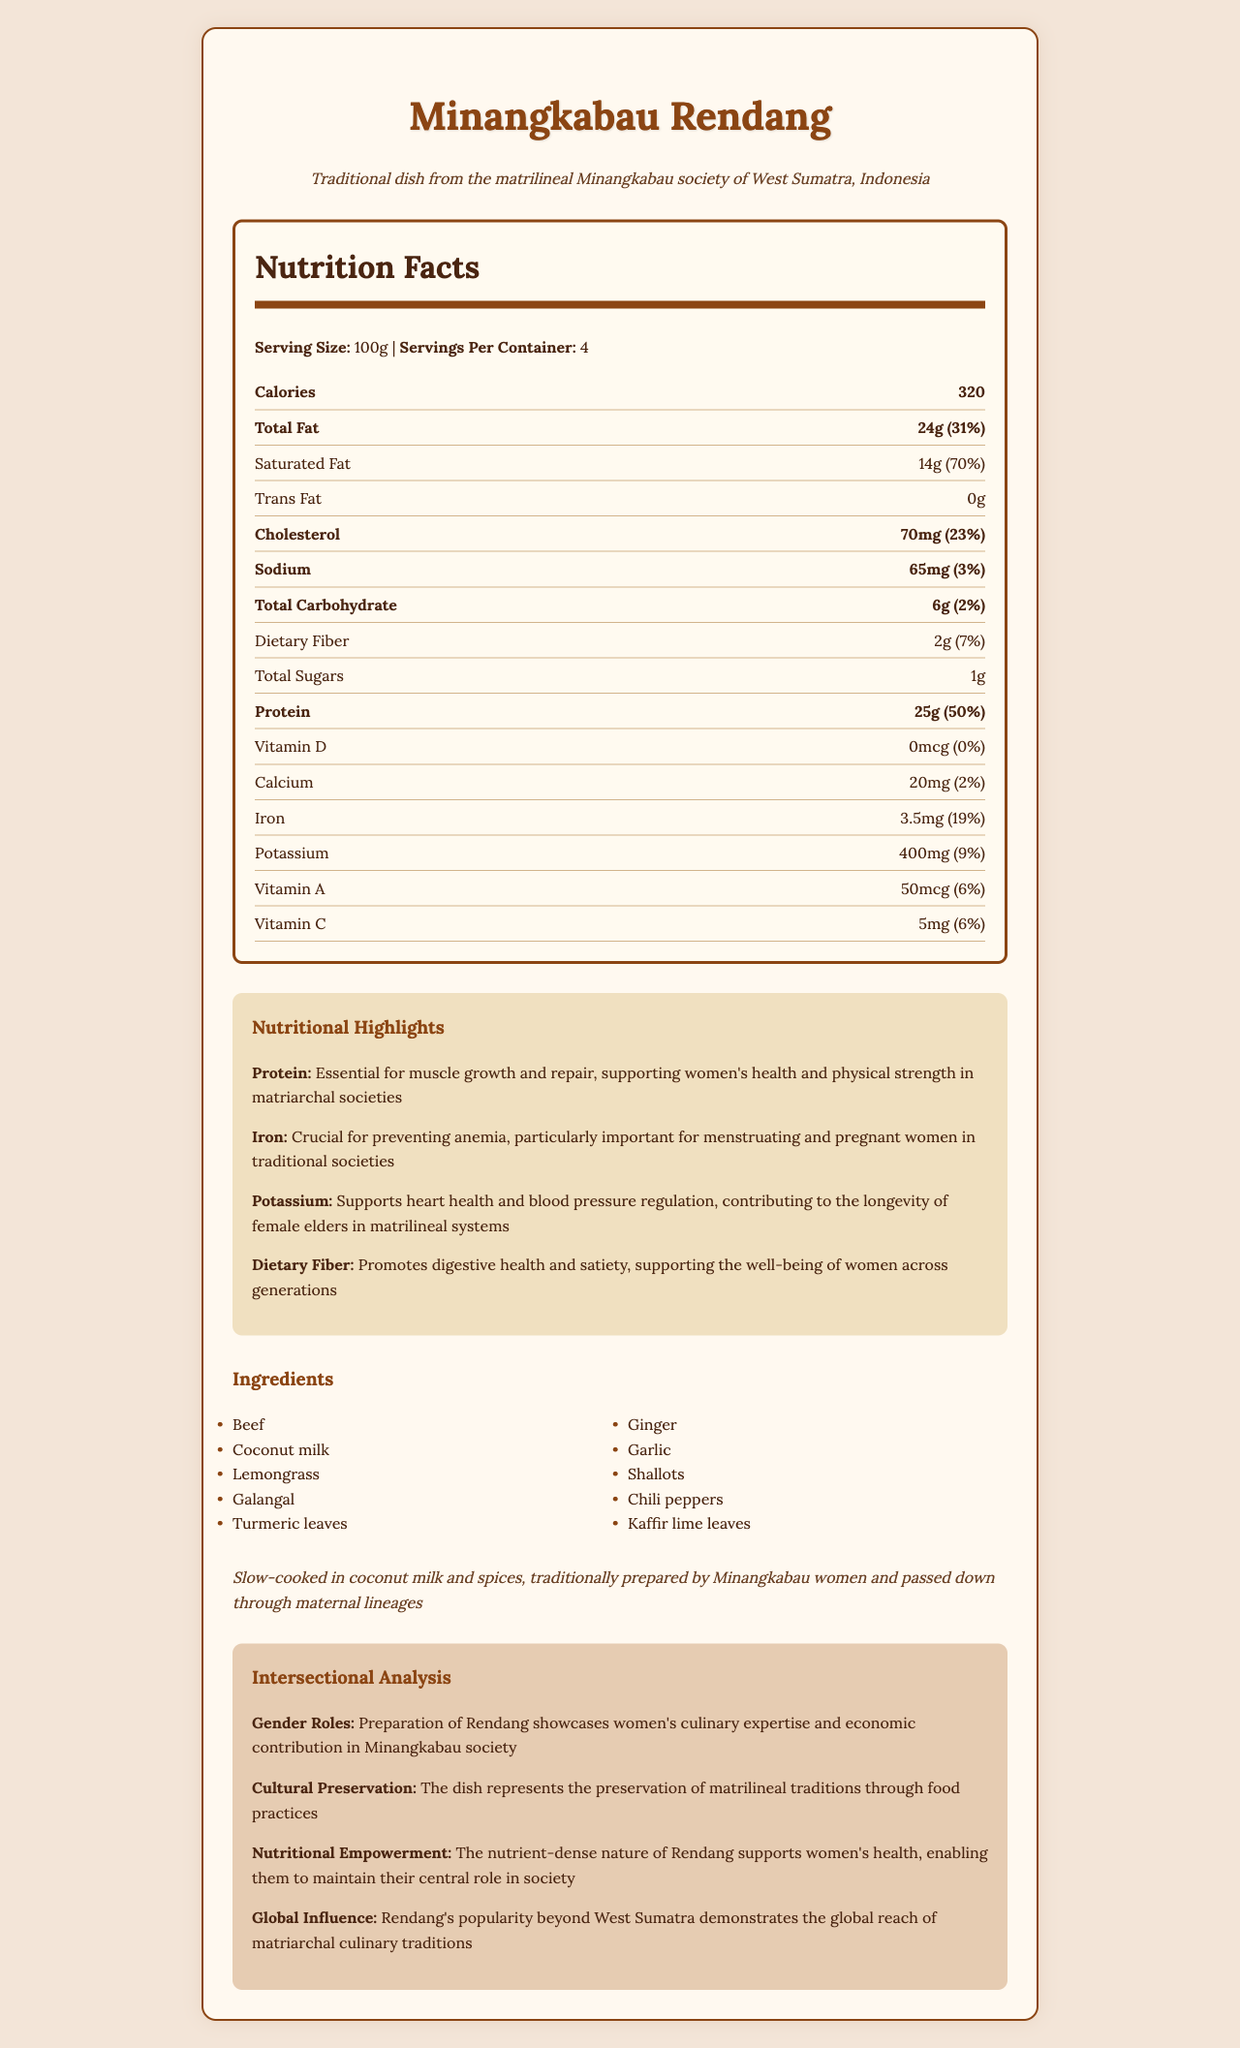what is the serving size for Minangkabau Rendang? The serving size is clearly stated in the Nutrition Facts section as "100g".
Answer: 100g how many calories are in one serving of Minangkabau Rendang? The document states that one serving contains 320 calories.
Answer: 320 how many grams of total fat are in a single serving? The label explicitly mentions that the total fat content per serving is 24g.
Answer: 24g what is the percentage of daily value for saturated fat? The Nutrition Facts section lists the daily value percentage for saturated fat as 70%.
Answer: 70% how much dietary fiber is in one serving? The amount of dietary fiber is provided as 2g per serving.
Answer: 2g what are two primary benefits of consuming Minangkabau Rendang listed in the highlights section? The highlights section mentions Protein for muscle growth and repair, and Iron for preventing anemia as primary benefits.
Answer: Protein and Iron how is Minangkabau Rendang traditionally prepared? A. Baked B. Stir-fried C. Slow-cooked D. Grilled The preparation method is specified as "Slow-cooked" in coconut milk and spices.
Answer: C which of the following nutrients has the highest daily value percentage in Minangkabau Rendang? A. Protein B. Sodium C. Iron D. Potassium Protein has the highest daily value percentage at 50%, which is confirmed in the Nutrition Facts section.
Answer: A does Minangkabau Rendang contain any trans fat? The label states that there is 0g of trans fat in the dish.
Answer: No what cultural role does the preparation of Minangkabau Rendang play in Minangkabau society? The intersectional analysis section mentions that the preparation of Rendang showcases women's culinary expertise and economic contribution in Minangkabau society.
Answer: It showcases women's culinary expertise and economic contribution. summarize the main idea of the document. This summary captures the overall content and focus of the document, including its nutritional and cultural aspects.
Answer: The document provides detailed nutritional information and cultural context for Minangkabau Rendang, a traditional dish from the matrilineal Minangkabau society. It highlights the dish's nutritional benefits, including high protein and iron content, and discusses its cultural significance, preparation methods, and impact on women's health and societal roles. how many servings are in a container of Minangkabau Rendang? The document specifies that there are 4 servings per container.
Answer: 4 what is the cholesterol content per serving? The Nutrition Facts section lists the cholesterol content as 70mg per serving.
Answer: 70mg identify one nutrient that does not contribute to the daily value percentage. The document states that Vitamin D has a daily value percentage of 0%.
Answer: Vitamin D which ingredient is used in making Minangkabau Rendang? A. Basil B. Lemongrass C. Cumin D. Rosemary Lemongrass is listed as one of the ingredients in the dish.
Answer: B what is the role of potassium in Minangkabau Rendang according to the nutritional highlights? The highlights section mentions that potassium supports heart health and blood pressure regulation.
Answer: Supports heart health and blood pressure regulation how much vitamin C is in a serving? The amount of Vitamin C per serving is listed as 5mg in the Nutrition Facts section.
Answer: 5mg how does the nutrient-dense nature of Rendang contribute to Minangkabau society? The intersectional analysis section explains that the nutrient-dense nature of Rendang supports women's health, enabling them to maintain their central role in Minangkabau society.
Answer: Supports women's health, enabling them to maintain their central role in society. what is the cultural significance of Minangkabau Rendang's preparation method? The intersectional analysis section points out that the dish's preparation method represents the preservation of matrilineal traditions through food practices.
Answer: It preserves matrilineal traditions through food practices. who introduced Rendang’s popularity beyond West Sumatra? The document mentions the dish's global reach but does not specify who introduced its popularity beyond West Sumatra.
Answer: Cannot be determined 